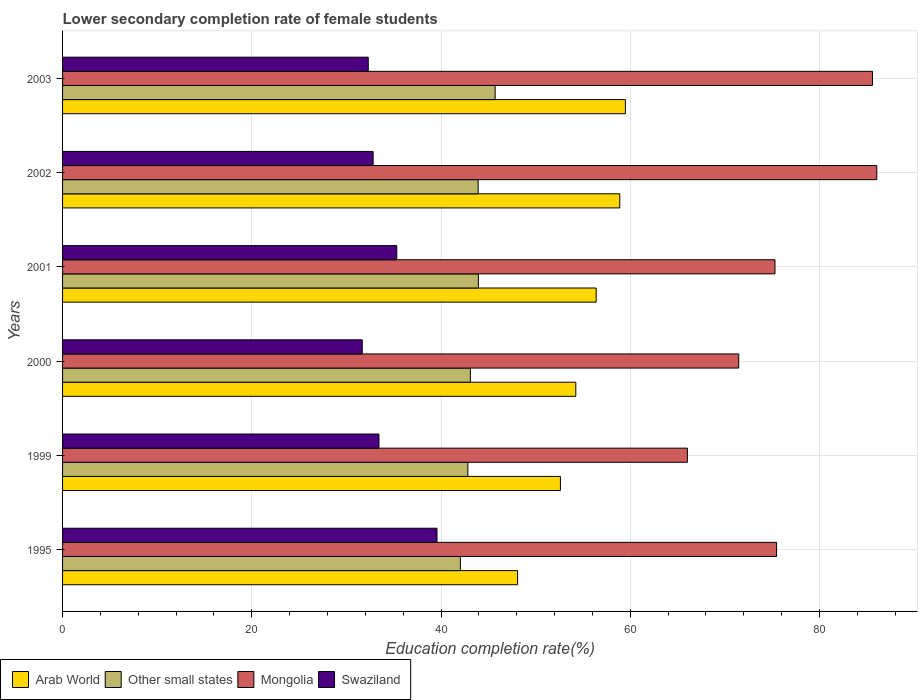How many different coloured bars are there?
Give a very brief answer. 4. Are the number of bars per tick equal to the number of legend labels?
Ensure brevity in your answer.  Yes. Are the number of bars on each tick of the Y-axis equal?
Provide a succinct answer. Yes. How many bars are there on the 5th tick from the top?
Ensure brevity in your answer.  4. How many bars are there on the 6th tick from the bottom?
Provide a succinct answer. 4. What is the lower secondary completion rate of female students in Mongolia in 2000?
Keep it short and to the point. 71.46. Across all years, what is the maximum lower secondary completion rate of female students in Swaziland?
Make the answer very short. 39.57. Across all years, what is the minimum lower secondary completion rate of female students in Other small states?
Your answer should be compact. 42.04. In which year was the lower secondary completion rate of female students in Mongolia maximum?
Provide a short and direct response. 2002. In which year was the lower secondary completion rate of female students in Arab World minimum?
Make the answer very short. 1995. What is the total lower secondary completion rate of female students in Mongolia in the graph?
Your response must be concise. 459.92. What is the difference between the lower secondary completion rate of female students in Mongolia in 1999 and that in 2003?
Make the answer very short. -19.56. What is the difference between the lower secondary completion rate of female students in Other small states in 1999 and the lower secondary completion rate of female students in Arab World in 2002?
Make the answer very short. -16.06. What is the average lower secondary completion rate of female students in Mongolia per year?
Offer a very short reply. 76.65. In the year 1999, what is the difference between the lower secondary completion rate of female students in Mongolia and lower secondary completion rate of female students in Swaziland?
Ensure brevity in your answer.  32.6. What is the ratio of the lower secondary completion rate of female students in Mongolia in 1999 to that in 2003?
Provide a short and direct response. 0.77. Is the lower secondary completion rate of female students in Swaziland in 1999 less than that in 2000?
Make the answer very short. No. Is the difference between the lower secondary completion rate of female students in Mongolia in 1995 and 2003 greater than the difference between the lower secondary completion rate of female students in Swaziland in 1995 and 2003?
Keep it short and to the point. No. What is the difference between the highest and the second highest lower secondary completion rate of female students in Other small states?
Ensure brevity in your answer.  1.77. What is the difference between the highest and the lowest lower secondary completion rate of female students in Arab World?
Provide a short and direct response. 11.4. In how many years, is the lower secondary completion rate of female students in Other small states greater than the average lower secondary completion rate of female students in Other small states taken over all years?
Provide a short and direct response. 3. Is the sum of the lower secondary completion rate of female students in Swaziland in 1995 and 2001 greater than the maximum lower secondary completion rate of female students in Other small states across all years?
Offer a terse response. Yes. Is it the case that in every year, the sum of the lower secondary completion rate of female students in Other small states and lower secondary completion rate of female students in Swaziland is greater than the sum of lower secondary completion rate of female students in Mongolia and lower secondary completion rate of female students in Arab World?
Offer a terse response. Yes. What does the 3rd bar from the top in 2003 represents?
Ensure brevity in your answer.  Other small states. What does the 4th bar from the bottom in 2001 represents?
Give a very brief answer. Swaziland. Is it the case that in every year, the sum of the lower secondary completion rate of female students in Arab World and lower secondary completion rate of female students in Other small states is greater than the lower secondary completion rate of female students in Mongolia?
Offer a terse response. Yes. Does the graph contain any zero values?
Your response must be concise. No. How many legend labels are there?
Provide a succinct answer. 4. How are the legend labels stacked?
Offer a terse response. Horizontal. What is the title of the graph?
Provide a short and direct response. Lower secondary completion rate of female students. What is the label or title of the X-axis?
Keep it short and to the point. Education completion rate(%). What is the Education completion rate(%) of Arab World in 1995?
Your answer should be very brief. 48.09. What is the Education completion rate(%) of Other small states in 1995?
Make the answer very short. 42.04. What is the Education completion rate(%) in Mongolia in 1995?
Make the answer very short. 75.46. What is the Education completion rate(%) in Swaziland in 1995?
Ensure brevity in your answer.  39.57. What is the Education completion rate(%) in Arab World in 1999?
Your response must be concise. 52.62. What is the Education completion rate(%) in Other small states in 1999?
Keep it short and to the point. 42.84. What is the Education completion rate(%) of Mongolia in 1999?
Ensure brevity in your answer.  66.04. What is the Education completion rate(%) in Swaziland in 1999?
Your answer should be very brief. 33.44. What is the Education completion rate(%) of Arab World in 2000?
Provide a succinct answer. 54.24. What is the Education completion rate(%) of Other small states in 2000?
Your response must be concise. 43.1. What is the Education completion rate(%) of Mongolia in 2000?
Provide a succinct answer. 71.46. What is the Education completion rate(%) in Swaziland in 2000?
Keep it short and to the point. 31.67. What is the Education completion rate(%) in Arab World in 2001?
Your response must be concise. 56.4. What is the Education completion rate(%) of Other small states in 2001?
Offer a very short reply. 43.95. What is the Education completion rate(%) of Mongolia in 2001?
Make the answer very short. 75.3. What is the Education completion rate(%) in Swaziland in 2001?
Ensure brevity in your answer.  35.32. What is the Education completion rate(%) of Arab World in 2002?
Provide a short and direct response. 58.89. What is the Education completion rate(%) in Other small states in 2002?
Provide a succinct answer. 43.92. What is the Education completion rate(%) in Mongolia in 2002?
Ensure brevity in your answer.  86.06. What is the Education completion rate(%) of Swaziland in 2002?
Your response must be concise. 32.82. What is the Education completion rate(%) of Arab World in 2003?
Your answer should be very brief. 59.49. What is the Education completion rate(%) in Other small states in 2003?
Give a very brief answer. 45.72. What is the Education completion rate(%) of Mongolia in 2003?
Provide a short and direct response. 85.6. What is the Education completion rate(%) in Swaziland in 2003?
Offer a very short reply. 32.31. Across all years, what is the maximum Education completion rate(%) of Arab World?
Your answer should be compact. 59.49. Across all years, what is the maximum Education completion rate(%) in Other small states?
Ensure brevity in your answer.  45.72. Across all years, what is the maximum Education completion rate(%) of Mongolia?
Give a very brief answer. 86.06. Across all years, what is the maximum Education completion rate(%) in Swaziland?
Make the answer very short. 39.57. Across all years, what is the minimum Education completion rate(%) of Arab World?
Your response must be concise. 48.09. Across all years, what is the minimum Education completion rate(%) of Other small states?
Provide a short and direct response. 42.04. Across all years, what is the minimum Education completion rate(%) of Mongolia?
Give a very brief answer. 66.04. Across all years, what is the minimum Education completion rate(%) of Swaziland?
Provide a short and direct response. 31.67. What is the total Education completion rate(%) of Arab World in the graph?
Offer a very short reply. 329.73. What is the total Education completion rate(%) of Other small states in the graph?
Your answer should be compact. 261.57. What is the total Education completion rate(%) of Mongolia in the graph?
Keep it short and to the point. 459.92. What is the total Education completion rate(%) of Swaziland in the graph?
Your answer should be very brief. 205.14. What is the difference between the Education completion rate(%) of Arab World in 1995 and that in 1999?
Offer a terse response. -4.53. What is the difference between the Education completion rate(%) in Other small states in 1995 and that in 1999?
Provide a short and direct response. -0.79. What is the difference between the Education completion rate(%) of Mongolia in 1995 and that in 1999?
Provide a succinct answer. 9.43. What is the difference between the Education completion rate(%) in Swaziland in 1995 and that in 1999?
Provide a succinct answer. 6.13. What is the difference between the Education completion rate(%) in Arab World in 1995 and that in 2000?
Your answer should be compact. -6.15. What is the difference between the Education completion rate(%) of Other small states in 1995 and that in 2000?
Keep it short and to the point. -1.06. What is the difference between the Education completion rate(%) in Mongolia in 1995 and that in 2000?
Ensure brevity in your answer.  4. What is the difference between the Education completion rate(%) of Swaziland in 1995 and that in 2000?
Your response must be concise. 7.9. What is the difference between the Education completion rate(%) of Arab World in 1995 and that in 2001?
Offer a terse response. -8.31. What is the difference between the Education completion rate(%) of Other small states in 1995 and that in 2001?
Your answer should be very brief. -1.9. What is the difference between the Education completion rate(%) of Mongolia in 1995 and that in 2001?
Offer a very short reply. 0.17. What is the difference between the Education completion rate(%) of Swaziland in 1995 and that in 2001?
Provide a succinct answer. 4.25. What is the difference between the Education completion rate(%) of Arab World in 1995 and that in 2002?
Your answer should be compact. -10.8. What is the difference between the Education completion rate(%) of Other small states in 1995 and that in 2002?
Provide a succinct answer. -1.88. What is the difference between the Education completion rate(%) of Mongolia in 1995 and that in 2002?
Offer a terse response. -10.59. What is the difference between the Education completion rate(%) in Swaziland in 1995 and that in 2002?
Provide a succinct answer. 6.75. What is the difference between the Education completion rate(%) in Arab World in 1995 and that in 2003?
Your answer should be very brief. -11.4. What is the difference between the Education completion rate(%) of Other small states in 1995 and that in 2003?
Your answer should be compact. -3.67. What is the difference between the Education completion rate(%) of Mongolia in 1995 and that in 2003?
Give a very brief answer. -10.14. What is the difference between the Education completion rate(%) of Swaziland in 1995 and that in 2003?
Your response must be concise. 7.26. What is the difference between the Education completion rate(%) of Arab World in 1999 and that in 2000?
Provide a short and direct response. -1.63. What is the difference between the Education completion rate(%) in Other small states in 1999 and that in 2000?
Make the answer very short. -0.27. What is the difference between the Education completion rate(%) of Mongolia in 1999 and that in 2000?
Your answer should be compact. -5.43. What is the difference between the Education completion rate(%) in Swaziland in 1999 and that in 2000?
Offer a very short reply. 1.77. What is the difference between the Education completion rate(%) of Arab World in 1999 and that in 2001?
Make the answer very short. -3.78. What is the difference between the Education completion rate(%) in Other small states in 1999 and that in 2001?
Offer a very short reply. -1.11. What is the difference between the Education completion rate(%) in Mongolia in 1999 and that in 2001?
Ensure brevity in your answer.  -9.26. What is the difference between the Education completion rate(%) of Swaziland in 1999 and that in 2001?
Your answer should be very brief. -1.88. What is the difference between the Education completion rate(%) of Arab World in 1999 and that in 2002?
Your answer should be very brief. -6.27. What is the difference between the Education completion rate(%) of Other small states in 1999 and that in 2002?
Your answer should be very brief. -1.09. What is the difference between the Education completion rate(%) in Mongolia in 1999 and that in 2002?
Keep it short and to the point. -20.02. What is the difference between the Education completion rate(%) in Swaziland in 1999 and that in 2002?
Provide a short and direct response. 0.62. What is the difference between the Education completion rate(%) of Arab World in 1999 and that in 2003?
Ensure brevity in your answer.  -6.87. What is the difference between the Education completion rate(%) in Other small states in 1999 and that in 2003?
Keep it short and to the point. -2.88. What is the difference between the Education completion rate(%) of Mongolia in 1999 and that in 2003?
Your response must be concise. -19.56. What is the difference between the Education completion rate(%) of Swaziland in 1999 and that in 2003?
Provide a short and direct response. 1.13. What is the difference between the Education completion rate(%) of Arab World in 2000 and that in 2001?
Provide a short and direct response. -2.15. What is the difference between the Education completion rate(%) of Other small states in 2000 and that in 2001?
Offer a very short reply. -0.84. What is the difference between the Education completion rate(%) of Mongolia in 2000 and that in 2001?
Your answer should be compact. -3.83. What is the difference between the Education completion rate(%) of Swaziland in 2000 and that in 2001?
Provide a succinct answer. -3.65. What is the difference between the Education completion rate(%) of Arab World in 2000 and that in 2002?
Give a very brief answer. -4.65. What is the difference between the Education completion rate(%) of Other small states in 2000 and that in 2002?
Make the answer very short. -0.82. What is the difference between the Education completion rate(%) in Mongolia in 2000 and that in 2002?
Keep it short and to the point. -14.59. What is the difference between the Education completion rate(%) in Swaziland in 2000 and that in 2002?
Your answer should be compact. -1.15. What is the difference between the Education completion rate(%) of Arab World in 2000 and that in 2003?
Keep it short and to the point. -5.24. What is the difference between the Education completion rate(%) in Other small states in 2000 and that in 2003?
Provide a succinct answer. -2.62. What is the difference between the Education completion rate(%) in Mongolia in 2000 and that in 2003?
Make the answer very short. -14.13. What is the difference between the Education completion rate(%) of Swaziland in 2000 and that in 2003?
Your response must be concise. -0.63. What is the difference between the Education completion rate(%) in Arab World in 2001 and that in 2002?
Ensure brevity in your answer.  -2.49. What is the difference between the Education completion rate(%) in Other small states in 2001 and that in 2002?
Offer a very short reply. 0.02. What is the difference between the Education completion rate(%) of Mongolia in 2001 and that in 2002?
Your response must be concise. -10.76. What is the difference between the Education completion rate(%) of Swaziland in 2001 and that in 2002?
Provide a short and direct response. 2.5. What is the difference between the Education completion rate(%) of Arab World in 2001 and that in 2003?
Provide a short and direct response. -3.09. What is the difference between the Education completion rate(%) of Other small states in 2001 and that in 2003?
Give a very brief answer. -1.77. What is the difference between the Education completion rate(%) of Mongolia in 2001 and that in 2003?
Your response must be concise. -10.3. What is the difference between the Education completion rate(%) of Swaziland in 2001 and that in 2003?
Give a very brief answer. 3.02. What is the difference between the Education completion rate(%) of Arab World in 2002 and that in 2003?
Offer a very short reply. -0.59. What is the difference between the Education completion rate(%) in Other small states in 2002 and that in 2003?
Provide a succinct answer. -1.79. What is the difference between the Education completion rate(%) in Mongolia in 2002 and that in 2003?
Provide a short and direct response. 0.46. What is the difference between the Education completion rate(%) of Swaziland in 2002 and that in 2003?
Offer a terse response. 0.51. What is the difference between the Education completion rate(%) of Arab World in 1995 and the Education completion rate(%) of Other small states in 1999?
Ensure brevity in your answer.  5.26. What is the difference between the Education completion rate(%) in Arab World in 1995 and the Education completion rate(%) in Mongolia in 1999?
Keep it short and to the point. -17.95. What is the difference between the Education completion rate(%) in Arab World in 1995 and the Education completion rate(%) in Swaziland in 1999?
Provide a succinct answer. 14.65. What is the difference between the Education completion rate(%) of Other small states in 1995 and the Education completion rate(%) of Mongolia in 1999?
Give a very brief answer. -23.99. What is the difference between the Education completion rate(%) in Other small states in 1995 and the Education completion rate(%) in Swaziland in 1999?
Keep it short and to the point. 8.61. What is the difference between the Education completion rate(%) of Mongolia in 1995 and the Education completion rate(%) of Swaziland in 1999?
Ensure brevity in your answer.  42.02. What is the difference between the Education completion rate(%) of Arab World in 1995 and the Education completion rate(%) of Other small states in 2000?
Give a very brief answer. 4.99. What is the difference between the Education completion rate(%) of Arab World in 1995 and the Education completion rate(%) of Mongolia in 2000?
Provide a succinct answer. -23.37. What is the difference between the Education completion rate(%) of Arab World in 1995 and the Education completion rate(%) of Swaziland in 2000?
Provide a succinct answer. 16.42. What is the difference between the Education completion rate(%) in Other small states in 1995 and the Education completion rate(%) in Mongolia in 2000?
Provide a short and direct response. -29.42. What is the difference between the Education completion rate(%) in Other small states in 1995 and the Education completion rate(%) in Swaziland in 2000?
Your answer should be compact. 10.37. What is the difference between the Education completion rate(%) of Mongolia in 1995 and the Education completion rate(%) of Swaziland in 2000?
Your response must be concise. 43.79. What is the difference between the Education completion rate(%) in Arab World in 1995 and the Education completion rate(%) in Other small states in 2001?
Your answer should be compact. 4.15. What is the difference between the Education completion rate(%) of Arab World in 1995 and the Education completion rate(%) of Mongolia in 2001?
Provide a succinct answer. -27.21. What is the difference between the Education completion rate(%) of Arab World in 1995 and the Education completion rate(%) of Swaziland in 2001?
Make the answer very short. 12.77. What is the difference between the Education completion rate(%) in Other small states in 1995 and the Education completion rate(%) in Mongolia in 2001?
Keep it short and to the point. -33.25. What is the difference between the Education completion rate(%) of Other small states in 1995 and the Education completion rate(%) of Swaziland in 2001?
Your response must be concise. 6.72. What is the difference between the Education completion rate(%) of Mongolia in 1995 and the Education completion rate(%) of Swaziland in 2001?
Your response must be concise. 40.14. What is the difference between the Education completion rate(%) of Arab World in 1995 and the Education completion rate(%) of Other small states in 2002?
Offer a terse response. 4.17. What is the difference between the Education completion rate(%) of Arab World in 1995 and the Education completion rate(%) of Mongolia in 2002?
Your answer should be compact. -37.96. What is the difference between the Education completion rate(%) in Arab World in 1995 and the Education completion rate(%) in Swaziland in 2002?
Ensure brevity in your answer.  15.27. What is the difference between the Education completion rate(%) of Other small states in 1995 and the Education completion rate(%) of Mongolia in 2002?
Provide a succinct answer. -44.01. What is the difference between the Education completion rate(%) of Other small states in 1995 and the Education completion rate(%) of Swaziland in 2002?
Give a very brief answer. 9.22. What is the difference between the Education completion rate(%) in Mongolia in 1995 and the Education completion rate(%) in Swaziland in 2002?
Ensure brevity in your answer.  42.64. What is the difference between the Education completion rate(%) in Arab World in 1995 and the Education completion rate(%) in Other small states in 2003?
Ensure brevity in your answer.  2.37. What is the difference between the Education completion rate(%) in Arab World in 1995 and the Education completion rate(%) in Mongolia in 2003?
Your answer should be very brief. -37.51. What is the difference between the Education completion rate(%) in Arab World in 1995 and the Education completion rate(%) in Swaziland in 2003?
Your answer should be compact. 15.78. What is the difference between the Education completion rate(%) in Other small states in 1995 and the Education completion rate(%) in Mongolia in 2003?
Provide a short and direct response. -43.55. What is the difference between the Education completion rate(%) of Other small states in 1995 and the Education completion rate(%) of Swaziland in 2003?
Your answer should be compact. 9.74. What is the difference between the Education completion rate(%) of Mongolia in 1995 and the Education completion rate(%) of Swaziland in 2003?
Make the answer very short. 43.16. What is the difference between the Education completion rate(%) in Arab World in 1999 and the Education completion rate(%) in Other small states in 2000?
Provide a short and direct response. 9.52. What is the difference between the Education completion rate(%) of Arab World in 1999 and the Education completion rate(%) of Mongolia in 2000?
Offer a very short reply. -18.84. What is the difference between the Education completion rate(%) of Arab World in 1999 and the Education completion rate(%) of Swaziland in 2000?
Your answer should be very brief. 20.95. What is the difference between the Education completion rate(%) in Other small states in 1999 and the Education completion rate(%) in Mongolia in 2000?
Offer a terse response. -28.63. What is the difference between the Education completion rate(%) in Other small states in 1999 and the Education completion rate(%) in Swaziland in 2000?
Your response must be concise. 11.16. What is the difference between the Education completion rate(%) of Mongolia in 1999 and the Education completion rate(%) of Swaziland in 2000?
Your answer should be very brief. 34.36. What is the difference between the Education completion rate(%) of Arab World in 1999 and the Education completion rate(%) of Other small states in 2001?
Your answer should be very brief. 8.67. What is the difference between the Education completion rate(%) in Arab World in 1999 and the Education completion rate(%) in Mongolia in 2001?
Your response must be concise. -22.68. What is the difference between the Education completion rate(%) in Arab World in 1999 and the Education completion rate(%) in Swaziland in 2001?
Your response must be concise. 17.3. What is the difference between the Education completion rate(%) in Other small states in 1999 and the Education completion rate(%) in Mongolia in 2001?
Your response must be concise. -32.46. What is the difference between the Education completion rate(%) of Other small states in 1999 and the Education completion rate(%) of Swaziland in 2001?
Make the answer very short. 7.51. What is the difference between the Education completion rate(%) in Mongolia in 1999 and the Education completion rate(%) in Swaziland in 2001?
Your answer should be compact. 30.71. What is the difference between the Education completion rate(%) in Arab World in 1999 and the Education completion rate(%) in Other small states in 2002?
Your answer should be compact. 8.7. What is the difference between the Education completion rate(%) of Arab World in 1999 and the Education completion rate(%) of Mongolia in 2002?
Provide a succinct answer. -33.44. What is the difference between the Education completion rate(%) in Arab World in 1999 and the Education completion rate(%) in Swaziland in 2002?
Your answer should be very brief. 19.8. What is the difference between the Education completion rate(%) in Other small states in 1999 and the Education completion rate(%) in Mongolia in 2002?
Give a very brief answer. -43.22. What is the difference between the Education completion rate(%) of Other small states in 1999 and the Education completion rate(%) of Swaziland in 2002?
Ensure brevity in your answer.  10.01. What is the difference between the Education completion rate(%) in Mongolia in 1999 and the Education completion rate(%) in Swaziland in 2002?
Offer a very short reply. 33.22. What is the difference between the Education completion rate(%) of Arab World in 1999 and the Education completion rate(%) of Other small states in 2003?
Offer a terse response. 6.9. What is the difference between the Education completion rate(%) of Arab World in 1999 and the Education completion rate(%) of Mongolia in 2003?
Your response must be concise. -32.98. What is the difference between the Education completion rate(%) of Arab World in 1999 and the Education completion rate(%) of Swaziland in 2003?
Your answer should be very brief. 20.31. What is the difference between the Education completion rate(%) of Other small states in 1999 and the Education completion rate(%) of Mongolia in 2003?
Your answer should be compact. -42.76. What is the difference between the Education completion rate(%) of Other small states in 1999 and the Education completion rate(%) of Swaziland in 2003?
Provide a succinct answer. 10.53. What is the difference between the Education completion rate(%) of Mongolia in 1999 and the Education completion rate(%) of Swaziland in 2003?
Provide a succinct answer. 33.73. What is the difference between the Education completion rate(%) in Arab World in 2000 and the Education completion rate(%) in Other small states in 2001?
Offer a very short reply. 10.3. What is the difference between the Education completion rate(%) of Arab World in 2000 and the Education completion rate(%) of Mongolia in 2001?
Offer a terse response. -21.05. What is the difference between the Education completion rate(%) in Arab World in 2000 and the Education completion rate(%) in Swaziland in 2001?
Offer a terse response. 18.92. What is the difference between the Education completion rate(%) of Other small states in 2000 and the Education completion rate(%) of Mongolia in 2001?
Give a very brief answer. -32.2. What is the difference between the Education completion rate(%) of Other small states in 2000 and the Education completion rate(%) of Swaziland in 2001?
Give a very brief answer. 7.78. What is the difference between the Education completion rate(%) of Mongolia in 2000 and the Education completion rate(%) of Swaziland in 2001?
Offer a terse response. 36.14. What is the difference between the Education completion rate(%) of Arab World in 2000 and the Education completion rate(%) of Other small states in 2002?
Ensure brevity in your answer.  10.32. What is the difference between the Education completion rate(%) of Arab World in 2000 and the Education completion rate(%) of Mongolia in 2002?
Keep it short and to the point. -31.81. What is the difference between the Education completion rate(%) of Arab World in 2000 and the Education completion rate(%) of Swaziland in 2002?
Provide a short and direct response. 21.42. What is the difference between the Education completion rate(%) of Other small states in 2000 and the Education completion rate(%) of Mongolia in 2002?
Keep it short and to the point. -42.95. What is the difference between the Education completion rate(%) in Other small states in 2000 and the Education completion rate(%) in Swaziland in 2002?
Make the answer very short. 10.28. What is the difference between the Education completion rate(%) of Mongolia in 2000 and the Education completion rate(%) of Swaziland in 2002?
Keep it short and to the point. 38.64. What is the difference between the Education completion rate(%) in Arab World in 2000 and the Education completion rate(%) in Other small states in 2003?
Your answer should be compact. 8.53. What is the difference between the Education completion rate(%) in Arab World in 2000 and the Education completion rate(%) in Mongolia in 2003?
Offer a terse response. -31.35. What is the difference between the Education completion rate(%) in Arab World in 2000 and the Education completion rate(%) in Swaziland in 2003?
Ensure brevity in your answer.  21.94. What is the difference between the Education completion rate(%) of Other small states in 2000 and the Education completion rate(%) of Mongolia in 2003?
Give a very brief answer. -42.5. What is the difference between the Education completion rate(%) in Other small states in 2000 and the Education completion rate(%) in Swaziland in 2003?
Offer a very short reply. 10.79. What is the difference between the Education completion rate(%) of Mongolia in 2000 and the Education completion rate(%) of Swaziland in 2003?
Offer a terse response. 39.16. What is the difference between the Education completion rate(%) of Arab World in 2001 and the Education completion rate(%) of Other small states in 2002?
Give a very brief answer. 12.47. What is the difference between the Education completion rate(%) in Arab World in 2001 and the Education completion rate(%) in Mongolia in 2002?
Ensure brevity in your answer.  -29.66. What is the difference between the Education completion rate(%) in Arab World in 2001 and the Education completion rate(%) in Swaziland in 2002?
Your answer should be compact. 23.58. What is the difference between the Education completion rate(%) in Other small states in 2001 and the Education completion rate(%) in Mongolia in 2002?
Your response must be concise. -42.11. What is the difference between the Education completion rate(%) of Other small states in 2001 and the Education completion rate(%) of Swaziland in 2002?
Provide a succinct answer. 11.12. What is the difference between the Education completion rate(%) of Mongolia in 2001 and the Education completion rate(%) of Swaziland in 2002?
Your answer should be compact. 42.47. What is the difference between the Education completion rate(%) of Arab World in 2001 and the Education completion rate(%) of Other small states in 2003?
Your response must be concise. 10.68. What is the difference between the Education completion rate(%) in Arab World in 2001 and the Education completion rate(%) in Mongolia in 2003?
Offer a very short reply. -29.2. What is the difference between the Education completion rate(%) of Arab World in 2001 and the Education completion rate(%) of Swaziland in 2003?
Your answer should be compact. 24.09. What is the difference between the Education completion rate(%) of Other small states in 2001 and the Education completion rate(%) of Mongolia in 2003?
Provide a succinct answer. -41.65. What is the difference between the Education completion rate(%) in Other small states in 2001 and the Education completion rate(%) in Swaziland in 2003?
Give a very brief answer. 11.64. What is the difference between the Education completion rate(%) in Mongolia in 2001 and the Education completion rate(%) in Swaziland in 2003?
Your response must be concise. 42.99. What is the difference between the Education completion rate(%) in Arab World in 2002 and the Education completion rate(%) in Other small states in 2003?
Offer a terse response. 13.17. What is the difference between the Education completion rate(%) of Arab World in 2002 and the Education completion rate(%) of Mongolia in 2003?
Provide a succinct answer. -26.71. What is the difference between the Education completion rate(%) of Arab World in 2002 and the Education completion rate(%) of Swaziland in 2003?
Your answer should be compact. 26.58. What is the difference between the Education completion rate(%) in Other small states in 2002 and the Education completion rate(%) in Mongolia in 2003?
Your answer should be very brief. -41.67. What is the difference between the Education completion rate(%) of Other small states in 2002 and the Education completion rate(%) of Swaziland in 2003?
Your response must be concise. 11.62. What is the difference between the Education completion rate(%) in Mongolia in 2002 and the Education completion rate(%) in Swaziland in 2003?
Your response must be concise. 53.75. What is the average Education completion rate(%) of Arab World per year?
Your response must be concise. 54.96. What is the average Education completion rate(%) of Other small states per year?
Offer a very short reply. 43.59. What is the average Education completion rate(%) of Mongolia per year?
Keep it short and to the point. 76.65. What is the average Education completion rate(%) in Swaziland per year?
Give a very brief answer. 34.19. In the year 1995, what is the difference between the Education completion rate(%) in Arab World and Education completion rate(%) in Other small states?
Your response must be concise. 6.05. In the year 1995, what is the difference between the Education completion rate(%) of Arab World and Education completion rate(%) of Mongolia?
Provide a short and direct response. -27.37. In the year 1995, what is the difference between the Education completion rate(%) of Arab World and Education completion rate(%) of Swaziland?
Offer a very short reply. 8.52. In the year 1995, what is the difference between the Education completion rate(%) in Other small states and Education completion rate(%) in Mongolia?
Ensure brevity in your answer.  -33.42. In the year 1995, what is the difference between the Education completion rate(%) of Other small states and Education completion rate(%) of Swaziland?
Give a very brief answer. 2.47. In the year 1995, what is the difference between the Education completion rate(%) of Mongolia and Education completion rate(%) of Swaziland?
Make the answer very short. 35.89. In the year 1999, what is the difference between the Education completion rate(%) in Arab World and Education completion rate(%) in Other small states?
Make the answer very short. 9.78. In the year 1999, what is the difference between the Education completion rate(%) of Arab World and Education completion rate(%) of Mongolia?
Provide a succinct answer. -13.42. In the year 1999, what is the difference between the Education completion rate(%) of Arab World and Education completion rate(%) of Swaziland?
Your answer should be compact. 19.18. In the year 1999, what is the difference between the Education completion rate(%) of Other small states and Education completion rate(%) of Mongolia?
Offer a terse response. -23.2. In the year 1999, what is the difference between the Education completion rate(%) in Other small states and Education completion rate(%) in Swaziland?
Your answer should be compact. 9.4. In the year 1999, what is the difference between the Education completion rate(%) of Mongolia and Education completion rate(%) of Swaziland?
Your response must be concise. 32.6. In the year 2000, what is the difference between the Education completion rate(%) in Arab World and Education completion rate(%) in Other small states?
Offer a terse response. 11.14. In the year 2000, what is the difference between the Education completion rate(%) of Arab World and Education completion rate(%) of Mongolia?
Your answer should be very brief. -17.22. In the year 2000, what is the difference between the Education completion rate(%) of Arab World and Education completion rate(%) of Swaziland?
Ensure brevity in your answer.  22.57. In the year 2000, what is the difference between the Education completion rate(%) of Other small states and Education completion rate(%) of Mongolia?
Offer a very short reply. -28.36. In the year 2000, what is the difference between the Education completion rate(%) of Other small states and Education completion rate(%) of Swaziland?
Your answer should be compact. 11.43. In the year 2000, what is the difference between the Education completion rate(%) of Mongolia and Education completion rate(%) of Swaziland?
Keep it short and to the point. 39.79. In the year 2001, what is the difference between the Education completion rate(%) of Arab World and Education completion rate(%) of Other small states?
Make the answer very short. 12.45. In the year 2001, what is the difference between the Education completion rate(%) of Arab World and Education completion rate(%) of Mongolia?
Provide a short and direct response. -18.9. In the year 2001, what is the difference between the Education completion rate(%) in Arab World and Education completion rate(%) in Swaziland?
Give a very brief answer. 21.08. In the year 2001, what is the difference between the Education completion rate(%) of Other small states and Education completion rate(%) of Mongolia?
Provide a succinct answer. -31.35. In the year 2001, what is the difference between the Education completion rate(%) in Other small states and Education completion rate(%) in Swaziland?
Offer a terse response. 8.62. In the year 2001, what is the difference between the Education completion rate(%) in Mongolia and Education completion rate(%) in Swaziland?
Keep it short and to the point. 39.97. In the year 2002, what is the difference between the Education completion rate(%) in Arab World and Education completion rate(%) in Other small states?
Provide a succinct answer. 14.97. In the year 2002, what is the difference between the Education completion rate(%) of Arab World and Education completion rate(%) of Mongolia?
Provide a short and direct response. -27.16. In the year 2002, what is the difference between the Education completion rate(%) in Arab World and Education completion rate(%) in Swaziland?
Give a very brief answer. 26.07. In the year 2002, what is the difference between the Education completion rate(%) in Other small states and Education completion rate(%) in Mongolia?
Your answer should be very brief. -42.13. In the year 2002, what is the difference between the Education completion rate(%) in Other small states and Education completion rate(%) in Swaziland?
Your response must be concise. 11.1. In the year 2002, what is the difference between the Education completion rate(%) in Mongolia and Education completion rate(%) in Swaziland?
Offer a very short reply. 53.23. In the year 2003, what is the difference between the Education completion rate(%) of Arab World and Education completion rate(%) of Other small states?
Make the answer very short. 13.77. In the year 2003, what is the difference between the Education completion rate(%) in Arab World and Education completion rate(%) in Mongolia?
Ensure brevity in your answer.  -26.11. In the year 2003, what is the difference between the Education completion rate(%) in Arab World and Education completion rate(%) in Swaziland?
Provide a succinct answer. 27.18. In the year 2003, what is the difference between the Education completion rate(%) of Other small states and Education completion rate(%) of Mongolia?
Offer a very short reply. -39.88. In the year 2003, what is the difference between the Education completion rate(%) of Other small states and Education completion rate(%) of Swaziland?
Provide a short and direct response. 13.41. In the year 2003, what is the difference between the Education completion rate(%) of Mongolia and Education completion rate(%) of Swaziland?
Ensure brevity in your answer.  53.29. What is the ratio of the Education completion rate(%) in Arab World in 1995 to that in 1999?
Provide a short and direct response. 0.91. What is the ratio of the Education completion rate(%) of Other small states in 1995 to that in 1999?
Provide a short and direct response. 0.98. What is the ratio of the Education completion rate(%) in Mongolia in 1995 to that in 1999?
Your answer should be very brief. 1.14. What is the ratio of the Education completion rate(%) in Swaziland in 1995 to that in 1999?
Offer a very short reply. 1.18. What is the ratio of the Education completion rate(%) of Arab World in 1995 to that in 2000?
Provide a short and direct response. 0.89. What is the ratio of the Education completion rate(%) of Other small states in 1995 to that in 2000?
Provide a succinct answer. 0.98. What is the ratio of the Education completion rate(%) of Mongolia in 1995 to that in 2000?
Your response must be concise. 1.06. What is the ratio of the Education completion rate(%) of Swaziland in 1995 to that in 2000?
Provide a short and direct response. 1.25. What is the ratio of the Education completion rate(%) of Arab World in 1995 to that in 2001?
Your answer should be compact. 0.85. What is the ratio of the Education completion rate(%) of Other small states in 1995 to that in 2001?
Your answer should be compact. 0.96. What is the ratio of the Education completion rate(%) in Swaziland in 1995 to that in 2001?
Keep it short and to the point. 1.12. What is the ratio of the Education completion rate(%) in Arab World in 1995 to that in 2002?
Offer a very short reply. 0.82. What is the ratio of the Education completion rate(%) of Other small states in 1995 to that in 2002?
Your response must be concise. 0.96. What is the ratio of the Education completion rate(%) in Mongolia in 1995 to that in 2002?
Your answer should be compact. 0.88. What is the ratio of the Education completion rate(%) of Swaziland in 1995 to that in 2002?
Your answer should be very brief. 1.21. What is the ratio of the Education completion rate(%) in Arab World in 1995 to that in 2003?
Give a very brief answer. 0.81. What is the ratio of the Education completion rate(%) in Other small states in 1995 to that in 2003?
Make the answer very short. 0.92. What is the ratio of the Education completion rate(%) in Mongolia in 1995 to that in 2003?
Offer a very short reply. 0.88. What is the ratio of the Education completion rate(%) of Swaziland in 1995 to that in 2003?
Provide a short and direct response. 1.22. What is the ratio of the Education completion rate(%) in Other small states in 1999 to that in 2000?
Your answer should be compact. 0.99. What is the ratio of the Education completion rate(%) of Mongolia in 1999 to that in 2000?
Make the answer very short. 0.92. What is the ratio of the Education completion rate(%) in Swaziland in 1999 to that in 2000?
Provide a succinct answer. 1.06. What is the ratio of the Education completion rate(%) of Arab World in 1999 to that in 2001?
Ensure brevity in your answer.  0.93. What is the ratio of the Education completion rate(%) of Other small states in 1999 to that in 2001?
Provide a short and direct response. 0.97. What is the ratio of the Education completion rate(%) of Mongolia in 1999 to that in 2001?
Give a very brief answer. 0.88. What is the ratio of the Education completion rate(%) in Swaziland in 1999 to that in 2001?
Your answer should be compact. 0.95. What is the ratio of the Education completion rate(%) of Arab World in 1999 to that in 2002?
Keep it short and to the point. 0.89. What is the ratio of the Education completion rate(%) of Other small states in 1999 to that in 2002?
Offer a terse response. 0.98. What is the ratio of the Education completion rate(%) in Mongolia in 1999 to that in 2002?
Your answer should be very brief. 0.77. What is the ratio of the Education completion rate(%) of Swaziland in 1999 to that in 2002?
Make the answer very short. 1.02. What is the ratio of the Education completion rate(%) in Arab World in 1999 to that in 2003?
Give a very brief answer. 0.88. What is the ratio of the Education completion rate(%) of Other small states in 1999 to that in 2003?
Keep it short and to the point. 0.94. What is the ratio of the Education completion rate(%) of Mongolia in 1999 to that in 2003?
Offer a very short reply. 0.77. What is the ratio of the Education completion rate(%) in Swaziland in 1999 to that in 2003?
Make the answer very short. 1.03. What is the ratio of the Education completion rate(%) of Arab World in 2000 to that in 2001?
Provide a short and direct response. 0.96. What is the ratio of the Education completion rate(%) of Other small states in 2000 to that in 2001?
Offer a very short reply. 0.98. What is the ratio of the Education completion rate(%) of Mongolia in 2000 to that in 2001?
Offer a very short reply. 0.95. What is the ratio of the Education completion rate(%) of Swaziland in 2000 to that in 2001?
Make the answer very short. 0.9. What is the ratio of the Education completion rate(%) of Arab World in 2000 to that in 2002?
Make the answer very short. 0.92. What is the ratio of the Education completion rate(%) in Other small states in 2000 to that in 2002?
Offer a very short reply. 0.98. What is the ratio of the Education completion rate(%) in Mongolia in 2000 to that in 2002?
Your answer should be very brief. 0.83. What is the ratio of the Education completion rate(%) of Swaziland in 2000 to that in 2002?
Provide a succinct answer. 0.96. What is the ratio of the Education completion rate(%) of Arab World in 2000 to that in 2003?
Keep it short and to the point. 0.91. What is the ratio of the Education completion rate(%) in Other small states in 2000 to that in 2003?
Your response must be concise. 0.94. What is the ratio of the Education completion rate(%) in Mongolia in 2000 to that in 2003?
Give a very brief answer. 0.83. What is the ratio of the Education completion rate(%) of Swaziland in 2000 to that in 2003?
Make the answer very short. 0.98. What is the ratio of the Education completion rate(%) in Arab World in 2001 to that in 2002?
Keep it short and to the point. 0.96. What is the ratio of the Education completion rate(%) of Other small states in 2001 to that in 2002?
Keep it short and to the point. 1. What is the ratio of the Education completion rate(%) of Swaziland in 2001 to that in 2002?
Offer a very short reply. 1.08. What is the ratio of the Education completion rate(%) of Arab World in 2001 to that in 2003?
Your answer should be compact. 0.95. What is the ratio of the Education completion rate(%) in Other small states in 2001 to that in 2003?
Make the answer very short. 0.96. What is the ratio of the Education completion rate(%) in Mongolia in 2001 to that in 2003?
Provide a succinct answer. 0.88. What is the ratio of the Education completion rate(%) in Swaziland in 2001 to that in 2003?
Keep it short and to the point. 1.09. What is the ratio of the Education completion rate(%) of Arab World in 2002 to that in 2003?
Offer a terse response. 0.99. What is the ratio of the Education completion rate(%) in Other small states in 2002 to that in 2003?
Your answer should be compact. 0.96. What is the ratio of the Education completion rate(%) in Mongolia in 2002 to that in 2003?
Give a very brief answer. 1.01. What is the ratio of the Education completion rate(%) in Swaziland in 2002 to that in 2003?
Provide a short and direct response. 1.02. What is the difference between the highest and the second highest Education completion rate(%) in Arab World?
Make the answer very short. 0.59. What is the difference between the highest and the second highest Education completion rate(%) of Other small states?
Your answer should be very brief. 1.77. What is the difference between the highest and the second highest Education completion rate(%) in Mongolia?
Offer a very short reply. 0.46. What is the difference between the highest and the second highest Education completion rate(%) of Swaziland?
Your answer should be compact. 4.25. What is the difference between the highest and the lowest Education completion rate(%) in Arab World?
Keep it short and to the point. 11.4. What is the difference between the highest and the lowest Education completion rate(%) in Other small states?
Give a very brief answer. 3.67. What is the difference between the highest and the lowest Education completion rate(%) in Mongolia?
Offer a very short reply. 20.02. What is the difference between the highest and the lowest Education completion rate(%) of Swaziland?
Keep it short and to the point. 7.9. 